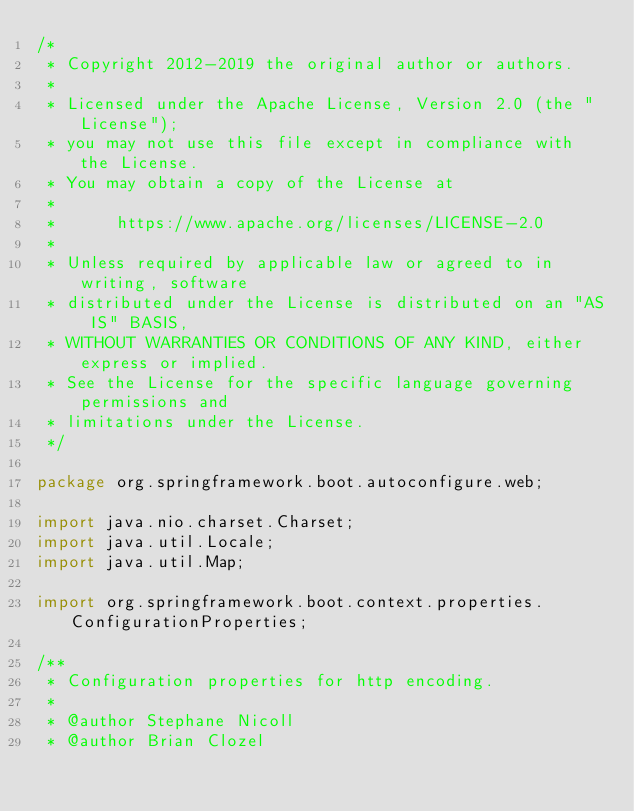Convert code to text. <code><loc_0><loc_0><loc_500><loc_500><_Java_>/*
 * Copyright 2012-2019 the original author or authors.
 *
 * Licensed under the Apache License, Version 2.0 (the "License");
 * you may not use this file except in compliance with the License.
 * You may obtain a copy of the License at
 *
 *      https://www.apache.org/licenses/LICENSE-2.0
 *
 * Unless required by applicable law or agreed to in writing, software
 * distributed under the License is distributed on an "AS IS" BASIS,
 * WITHOUT WARRANTIES OR CONDITIONS OF ANY KIND, either express or implied.
 * See the License for the specific language governing permissions and
 * limitations under the License.
 */

package org.springframework.boot.autoconfigure.web;

import java.nio.charset.Charset;
import java.util.Locale;
import java.util.Map;

import org.springframework.boot.context.properties.ConfigurationProperties;

/**
 * Configuration properties for http encoding.
 *
 * @author Stephane Nicoll
 * @author Brian Clozel</code> 